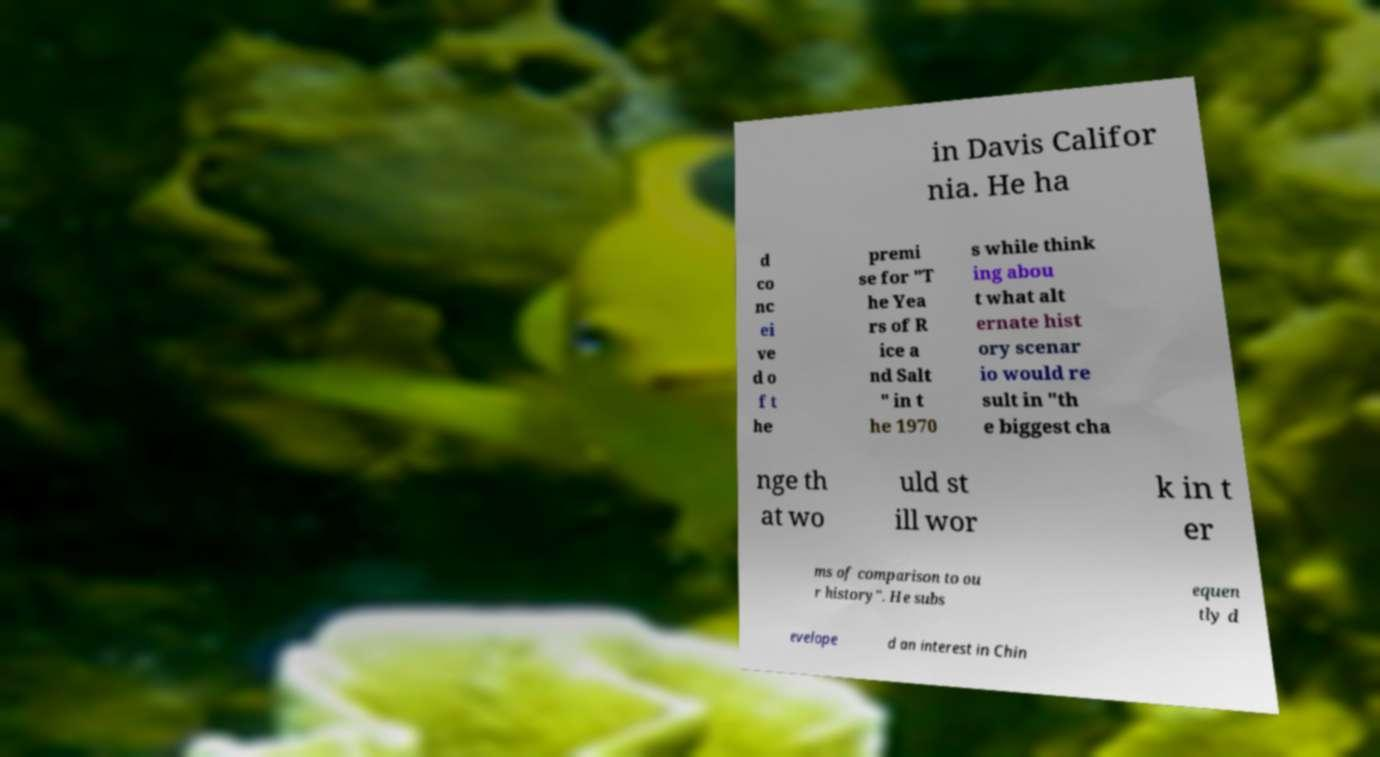Could you assist in decoding the text presented in this image and type it out clearly? in Davis Califor nia. He ha d co nc ei ve d o f t he premi se for "T he Yea rs of R ice a nd Salt " in t he 1970 s while think ing abou t what alt ernate hist ory scenar io would re sult in "th e biggest cha nge th at wo uld st ill wor k in t er ms of comparison to ou r history". He subs equen tly d evelope d an interest in Chin 